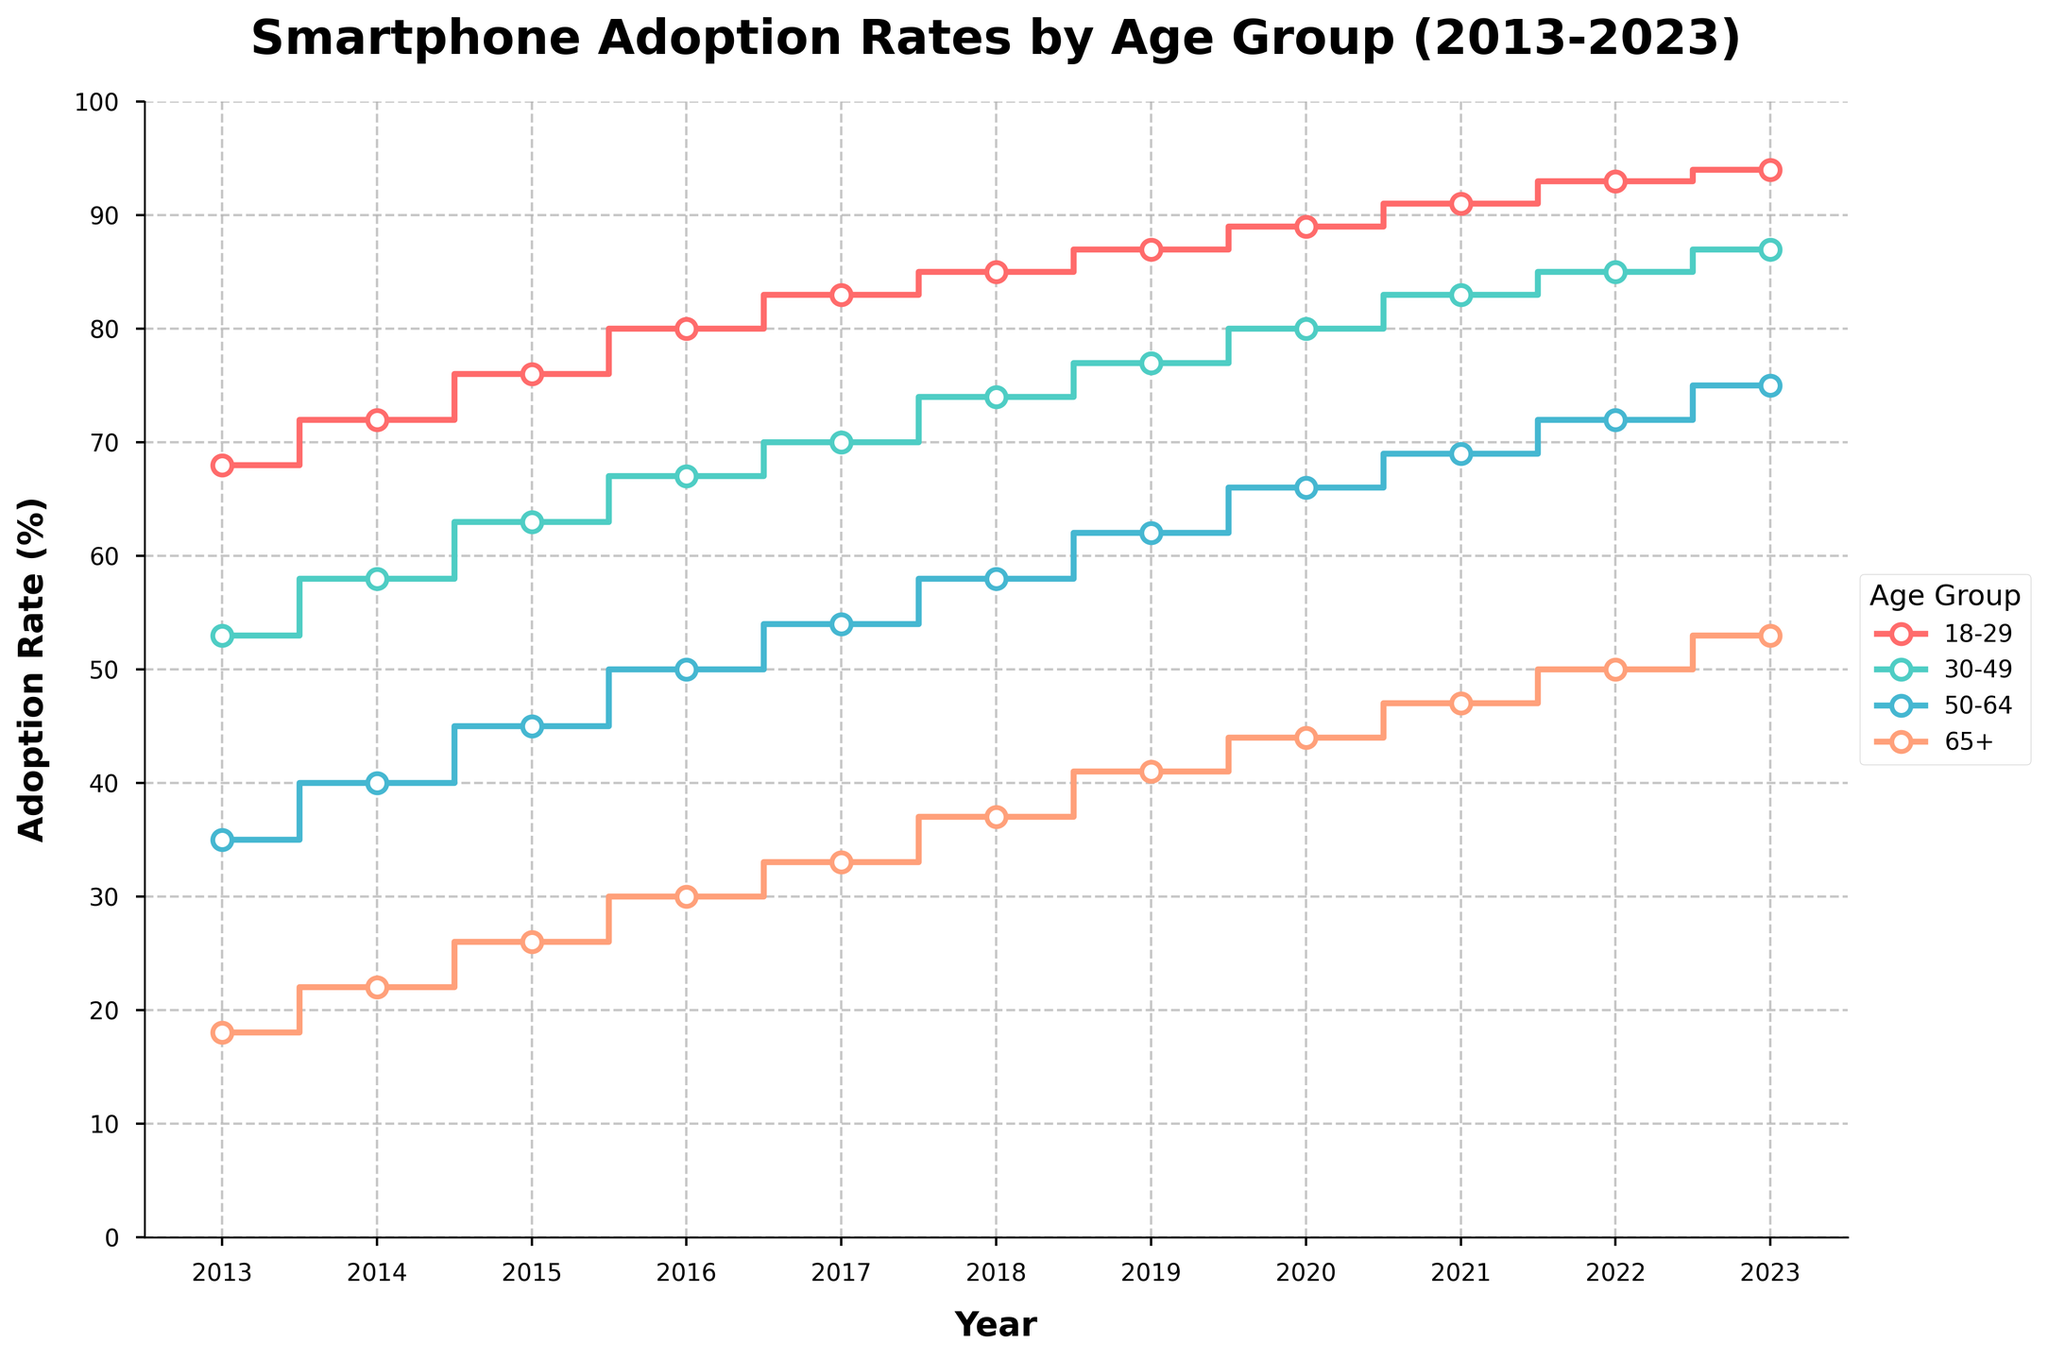What is the title of the figure? The title is usually located at the top of the figure and often explains what the figure is about. In this case, it is "Smartphone Adoption Rates by Age Group (2013-2023)" as it describes the trends over time for different age groups.
Answer: Smartphone Adoption Rates by Age Group (2013-2023) How many age groups are represented in the plot? By looking at the legend on the right side of the plot, we can see four different age groups listed: "18-29", "30-49", "50-64", and "65+".
Answer: 4 Which age group saw the highest adoption rate in 2023? By looking at the 2023 data points, which are the rightmost points in the plot, the highest rate appears on the line labeled "18-29". The value for this group in 2023 is 94%.
Answer: 18-29 What was the adoption rate for the 65+ age group in 2013? Locate the line for the 65+ group and trace it back to the point for the year 2013, which is the leftmost point for this group. The adoption rate is 18%.
Answer: 18% How much did the adoption rate increase for the 30-49 age group from 2013 to 2023? By looking at the data points for the 30-49 age group in 2013 and 2023, we find the values 53% and 87% respectively. The increase can be calculated as 87 - 53 = 34%.
Answer: 34% Which year did the 18-29 age group surpass the 80% adoption rate? Trace the 18-29 line and find the year where it first crosses the 80% mark. This occurred between 2015 and 2016, specifically in 2016 when the adoption rate reached 80%.
Answer: 2016 What is the average adoption rate for the 50-64 age group across the entire period? To find the average, sum the rates for the 50-64 age group for each year and divide by the number of years. (35 + 40 + 45 + 50 + 54 + 58 + 62 + 66 + 69 + 72 + 75) / 11 = 55.91%
Answer: 55.91% How does the adoption rate change for the 65+ age group from 2017 to 2023? Identify the adoption rates for the 65+ group in 2017 and 2023, which are 33% and 53% respectively. The change can be calculated as 53 - 33 = 20%.
Answer: 20% In which year did all age groups have an adoption rate greater than 50%? By examining the lines for each age group, we see that by 2019, all groups had surpassed the 50% mark, with 65+ being the last to reach 51%.
Answer: 2019 Which age group had the most constant increase in smartphone adoption rates over the years? By observing the stair-step plots, we see that the 18-29 age group has a steady and consistent increase without any significant dips or irregularities.
Answer: 18-29 